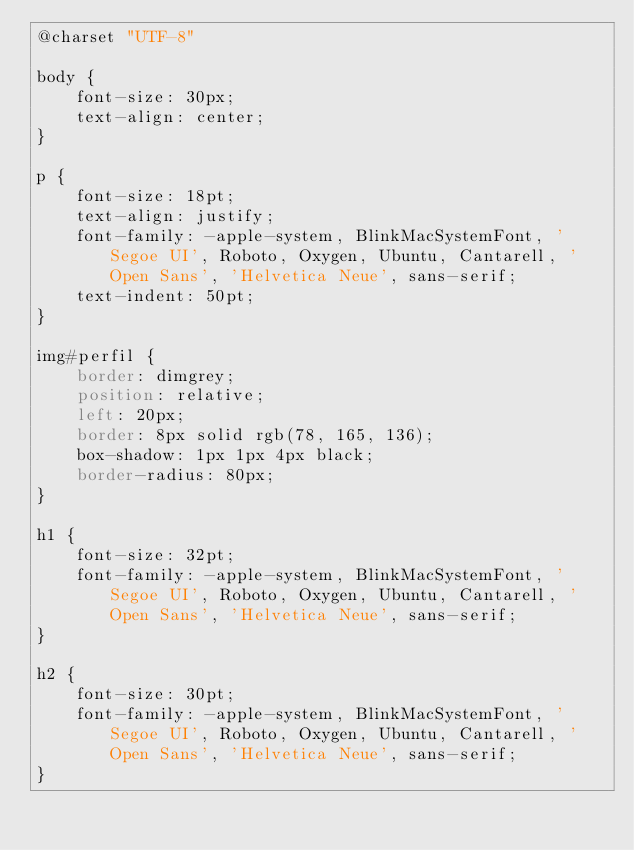<code> <loc_0><loc_0><loc_500><loc_500><_CSS_>@charset "UTF-8"

body {
    font-size: 30px;
    text-align: center;
}

p {
    font-size: 18pt;
    text-align: justify;
    font-family: -apple-system, BlinkMacSystemFont, 'Segoe UI', Roboto, Oxygen, Ubuntu, Cantarell, 'Open Sans', 'Helvetica Neue', sans-serif;
    text-indent: 50pt;
}

img#perfil {
    border: dimgrey;
    position: relative;
    left: 20px;
    border: 8px solid rgb(78, 165, 136);
    box-shadow: 1px 1px 4px black;
    border-radius: 80px;
}

h1 {
    font-size: 32pt;
    font-family: -apple-system, BlinkMacSystemFont, 'Segoe UI', Roboto, Oxygen, Ubuntu, Cantarell, 'Open Sans', 'Helvetica Neue', sans-serif;
}

h2 {
    font-size: 30pt;
    font-family: -apple-system, BlinkMacSystemFont, 'Segoe UI', Roboto, Oxygen, Ubuntu, Cantarell, 'Open Sans', 'Helvetica Neue', sans-serif;
}
</code> 